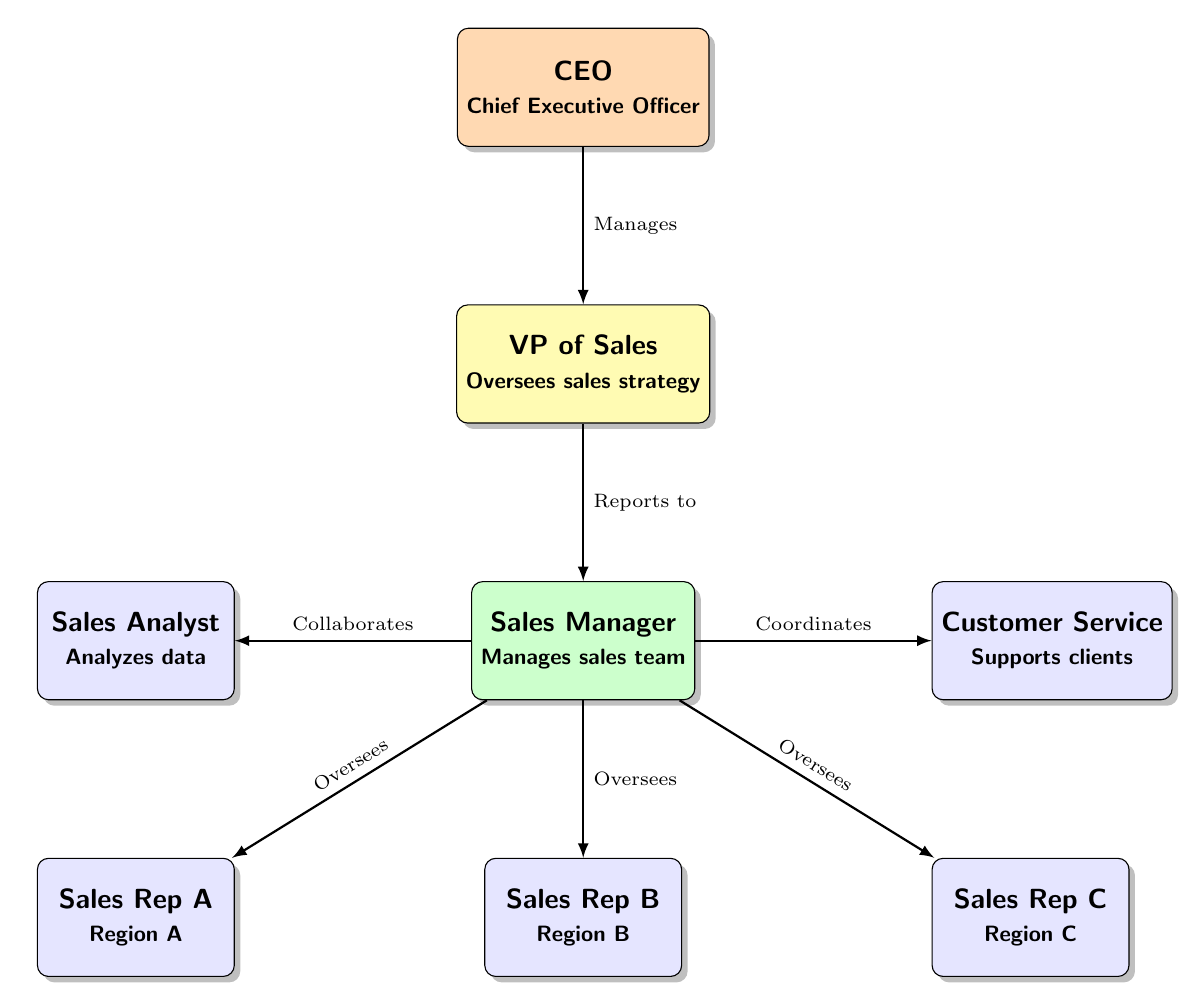What is the role of the person at the top of the organizational chart? The top node labeled "CEO" represents the Chief Executive Officer, who is responsible for overall management and direction of the organization.
Answer: Chief Executive Officer How many sales representatives are shown in the diagram? The diagram has three nodes labeled "Sales Rep A," "Sales Rep B," and "Sales Rep C," indicating there are three sales representatives in total.
Answer: 3 Who does the VP of Sales oversee? The VP of Sales is indicated to oversee the Sales Manager, as shown by the arrow connecting these two nodes.
Answer: Sales Manager What role does the Sales Analyst play in relation to the Sales Manager? The Sales Analyst collaborates with the Sales Manager, as depicted by the arrow connecting them, which indicates a working relationship between the two.
Answer: Collaborates Which position directly reports to the CEO? The position directly below the CEO in the chart is the VP of Sales, which shows a direct reporting line indicated by the connecting arrow.
Answer: VP of Sales Which role supports clients within the organization? The node labeled "Customer Service" is explicitly mentioned to support clients, indicating its primary responsibility within the sales team.
Answer: Customer Service What is the main responsibility of the Sales Manager? The Sales Manager's role is to manage the sales team, as highlighted in the node description below their title in the diagram.
Answer: Manages sales team In what way does the Sales Manager interact with the Sales Representatives? The Sales Manager oversees all the Sales Representatives as indicated by arrows pointing from the Sales Manager to each representative, showing a supervisory relationship.
Answer: Oversees Who coordinates with customer service in this sales team? The Sales Manager coordinates with the Customer Service role according to the diagram, as shown by the arrow linking these two positions.
Answer: Coordinates 